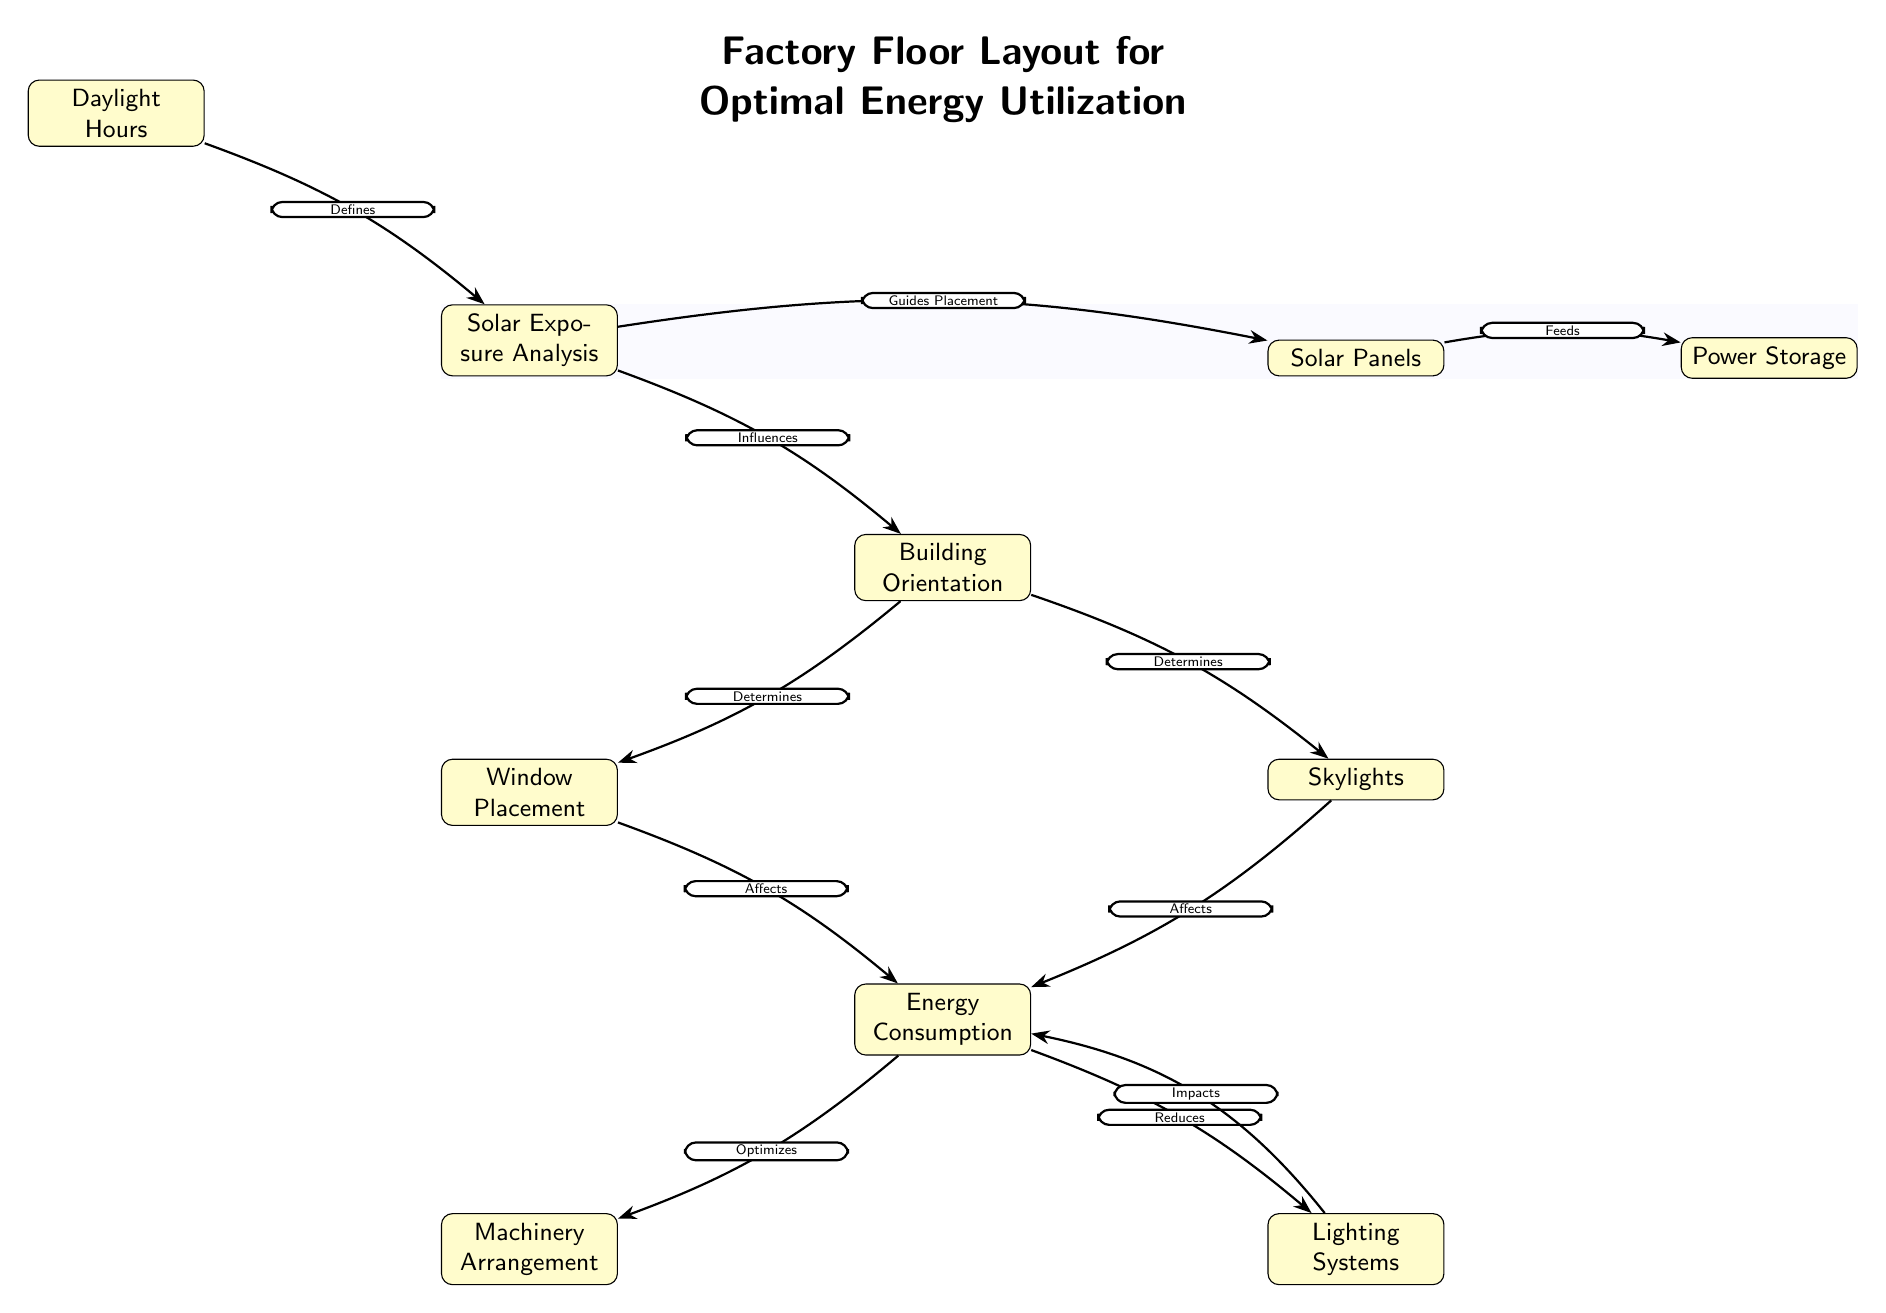What's the main focus of the diagram? The title of the diagram states "Factory Floor Layout for Optimal Energy Utilization," indicating that the diagram is centered around designing a factory layout that maximizes energy efficiency through solar exposure.
Answer: Factory Floor Layout for Optimal Energy Utilization How many primary nodes are in the diagram? The primary nodes in the diagram are: Solar Exposure Analysis, Building Orientation, Window Placement, Skylights, Energy Consumption, Machinery Arrangement, Lighting Systems, Solar Panels, Daylight Hours, and Power Storage. This totals to ten nodes.
Answer: Ten What influences Building Orientation? According to the diagram, Solar Exposure Analysis directly influences Building Orientation, as indicated by the edge label "Influences" connecting these two nodes.
Answer: Solar Exposure Analysis What does Window Placement affect? The diagram shows that Window Placement affects Energy Consumption, as indicated by the connection labeled "Affects" between these two nodes.
Answer: Energy Consumption Which factor guides the placement of Solar Panels? Solar Exposure Analysis guides the placement of Solar Panels, as demonstrated by the edge labeled "Guides Placement" connecting these two nodes.
Answer: Solar Exposure Analysis How does Energy Consumption optimize Machinery Arrangement? The diagram illustrates that Energy Consumption directly influences Machinery Arrangement, utilizing the term "Optimizes" for this relationship, suggesting that managing energy consumption can lead to a better arrangement of machinery.
Answer: Optimizes What defines Solar Exposure Analysis? The diagram indicates that Daylight Hours defines Solar Exposure Analysis, with the connecting edge labeled "Defines," suggesting that the amount of daylight determines how solar exposure is analyzed for effective energy use.
Answer: Daylight Hours How does Lighting Systems impact Energy Consumption? The edge labeled "Impacts" shows a relationship where Lighting Systems impact Energy Consumption, implying that the choice and arrangement of lighting systems directly correlate with how much energy is consumed.
Answer: Impacts Which node feeds into Power Storage? The node Solar Panels feeds into Power Storage, as evidenced by the connection labeled "Feeds," meaning that energy generated by solar panels is transferred to power storage systems.
Answer: Solar Panels 